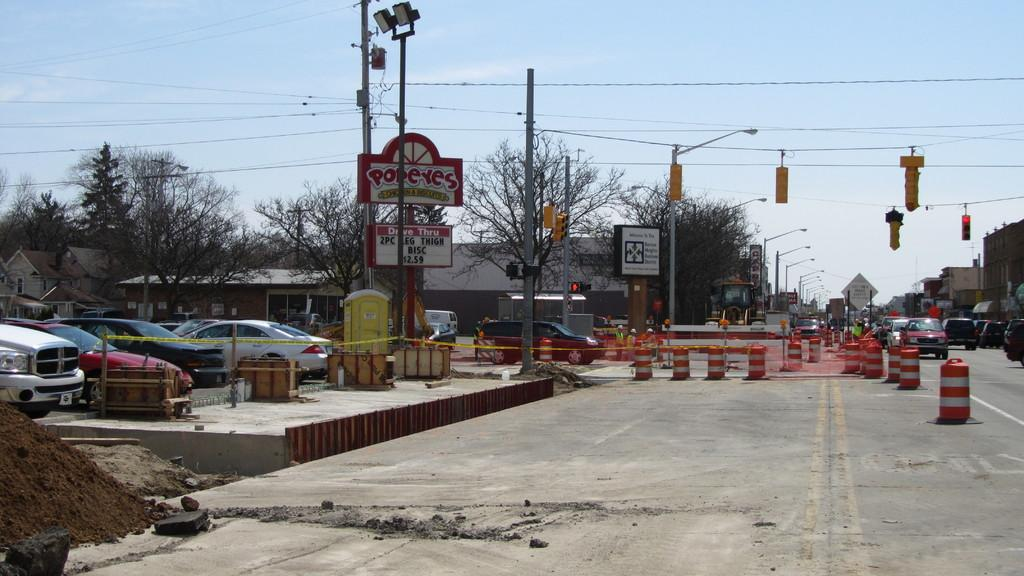Provide a one-sentence caption for the provided image. a street in the day with a Pop Eyes chicken building. 